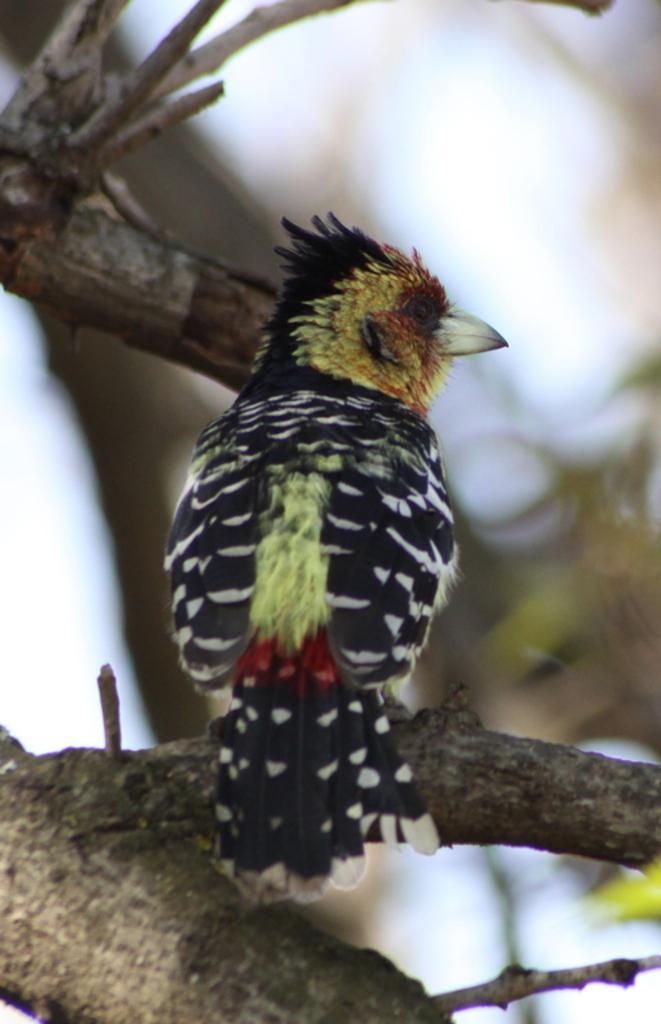How would you summarize this image in a sentence or two? In this image there is a bird standing on the branch of a tree, and there is blur background. 